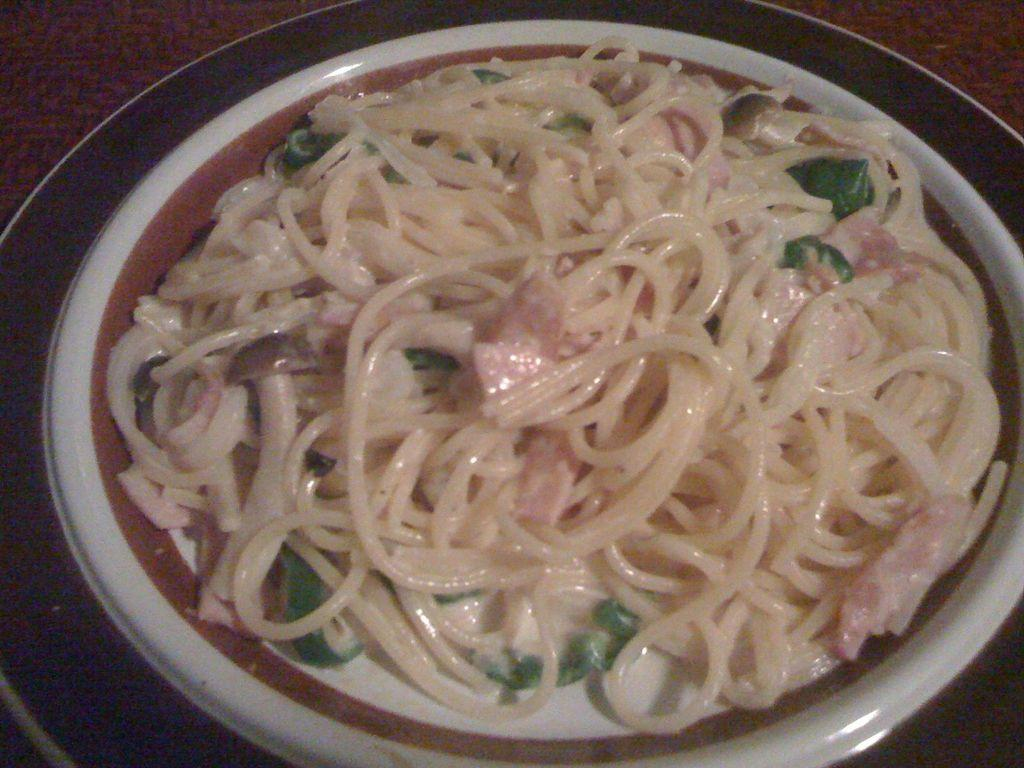What is on the plate that is visible in the image? The plate contains noodles, mushrooms, and other ingredients. Can you describe the other ingredients on the plate? Unfortunately, the specific other ingredients are not mentioned in the provided facts. How many different types of ingredients are on the plate? There are at least three different types of ingredients on the plate: noodles, mushrooms, and other ingredients. What type of lead can be seen on the plate in the image? There is no lead present on the plate in the image; it contains noodles, mushrooms, and other ingredients. 